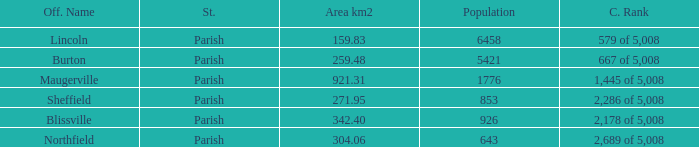What are the census ranking(s) of maugerville? 1,445 of 5,008. 